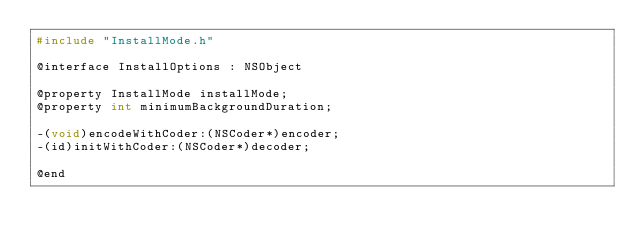<code> <loc_0><loc_0><loc_500><loc_500><_C_>#include "InstallMode.h"

@interface InstallOptions : NSObject

@property InstallMode installMode;
@property int minimumBackgroundDuration;

-(void)encodeWithCoder:(NSCoder*)encoder;
-(id)initWithCoder:(NSCoder*)decoder;

@end</code> 